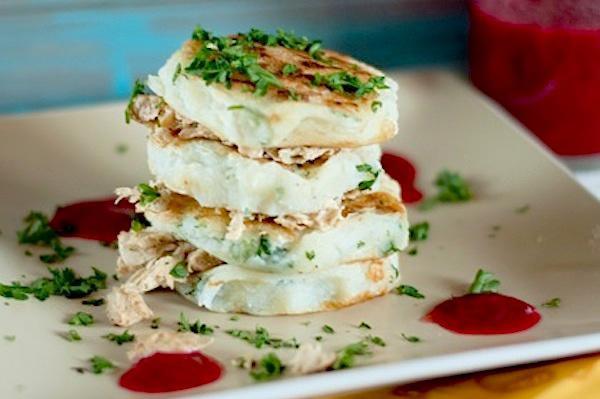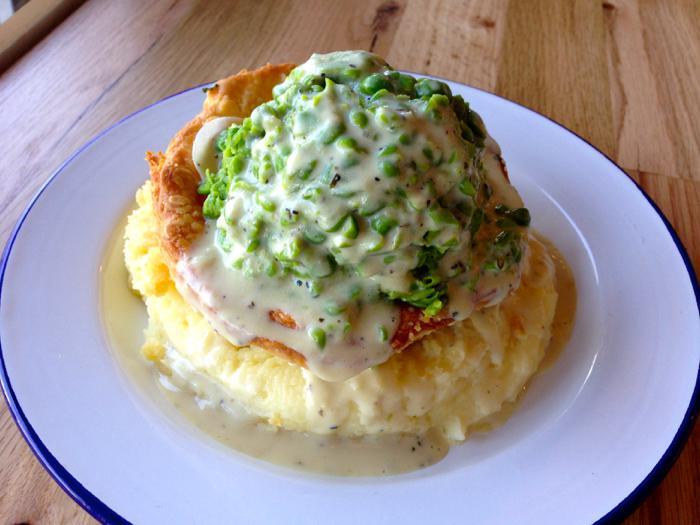The first image is the image on the left, the second image is the image on the right. Considering the images on both sides, is "One image shows a vertical stack of at least four 'solid' food items including similar items, and the other image shows a base food item with some other food item on top of it." valid? Answer yes or no. Yes. The first image is the image on the left, the second image is the image on the right. Considering the images on both sides, is "One of the entrees is a stack of different layers." valid? Answer yes or no. Yes. 